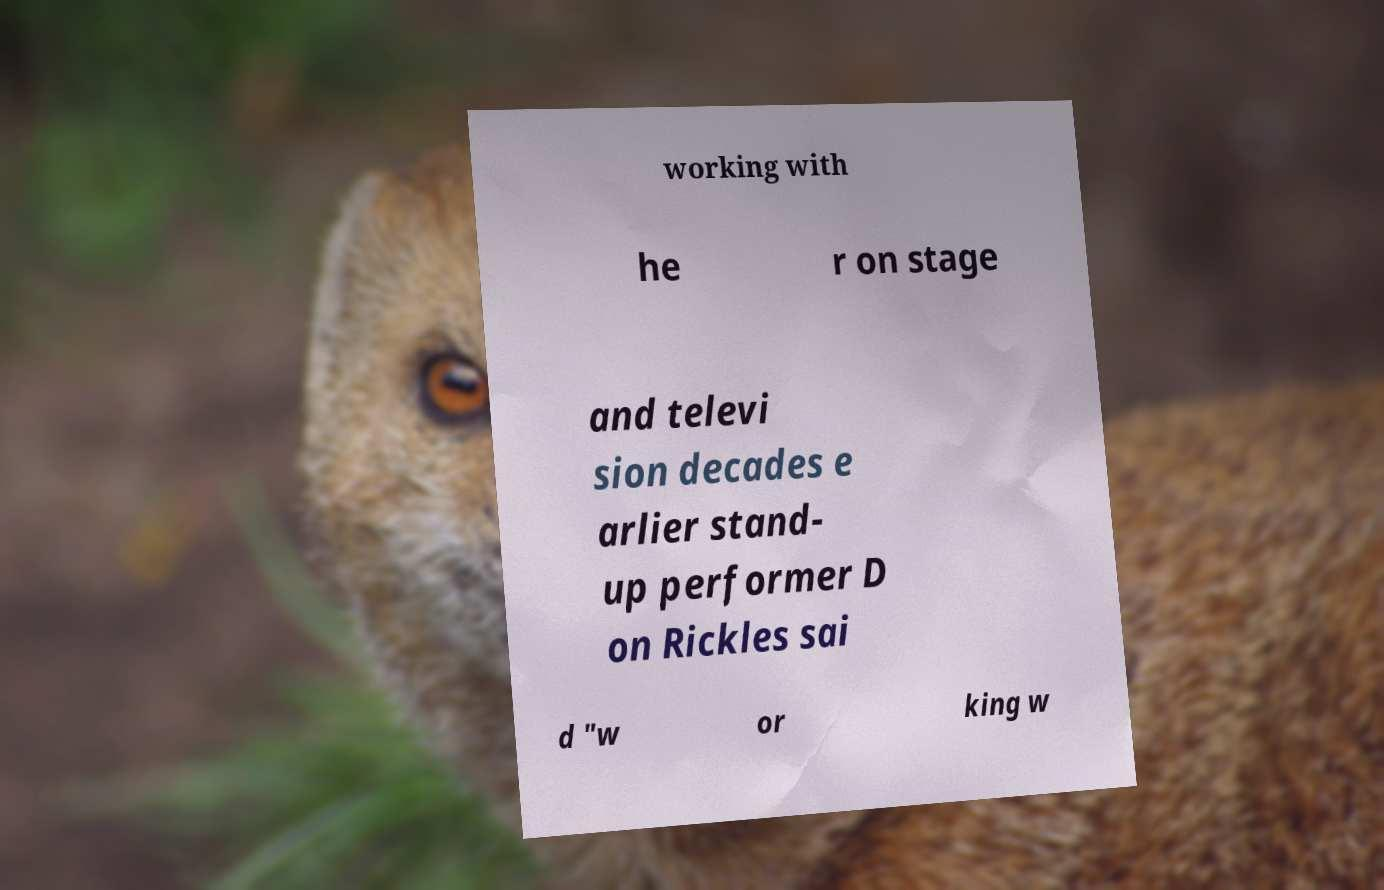Can you accurately transcribe the text from the provided image for me? working with he r on stage and televi sion decades e arlier stand- up performer D on Rickles sai d "w or king w 